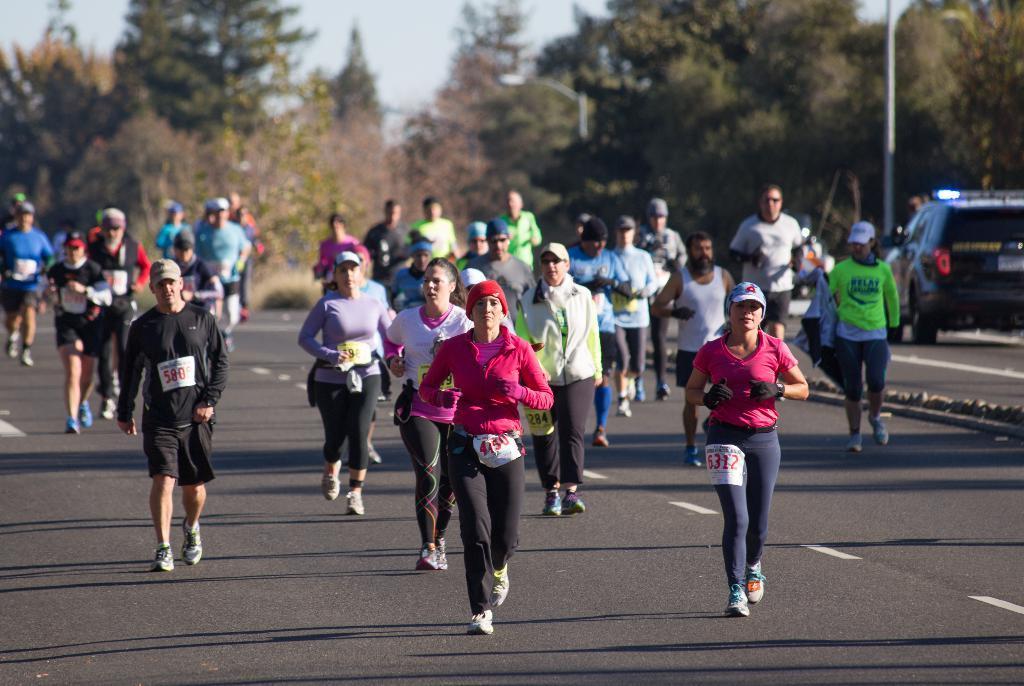Could you give a brief overview of what you see in this image? In this image there are group of people who are jogging on the road. All the people are having a number badge with them. In the background there are trees. On the right side there is a car on the road, Beside the car there is a pole. 